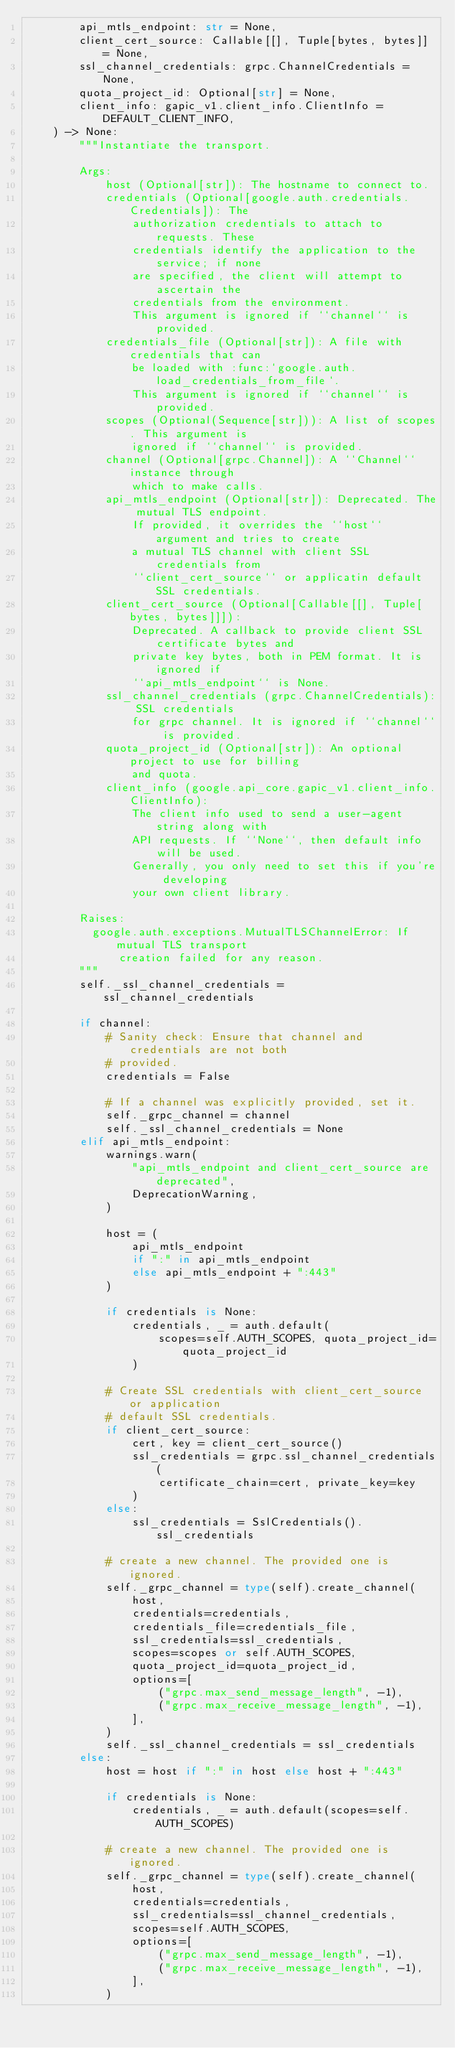Convert code to text. <code><loc_0><loc_0><loc_500><loc_500><_Python_>        api_mtls_endpoint: str = None,
        client_cert_source: Callable[[], Tuple[bytes, bytes]] = None,
        ssl_channel_credentials: grpc.ChannelCredentials = None,
        quota_project_id: Optional[str] = None,
        client_info: gapic_v1.client_info.ClientInfo = DEFAULT_CLIENT_INFO,
    ) -> None:
        """Instantiate the transport.

        Args:
            host (Optional[str]): The hostname to connect to.
            credentials (Optional[google.auth.credentials.Credentials]): The
                authorization credentials to attach to requests. These
                credentials identify the application to the service; if none
                are specified, the client will attempt to ascertain the
                credentials from the environment.
                This argument is ignored if ``channel`` is provided.
            credentials_file (Optional[str]): A file with credentials that can
                be loaded with :func:`google.auth.load_credentials_from_file`.
                This argument is ignored if ``channel`` is provided.
            scopes (Optional(Sequence[str])): A list of scopes. This argument is
                ignored if ``channel`` is provided.
            channel (Optional[grpc.Channel]): A ``Channel`` instance through
                which to make calls.
            api_mtls_endpoint (Optional[str]): Deprecated. The mutual TLS endpoint.
                If provided, it overrides the ``host`` argument and tries to create
                a mutual TLS channel with client SSL credentials from
                ``client_cert_source`` or applicatin default SSL credentials.
            client_cert_source (Optional[Callable[[], Tuple[bytes, bytes]]]):
                Deprecated. A callback to provide client SSL certificate bytes and
                private key bytes, both in PEM format. It is ignored if
                ``api_mtls_endpoint`` is None.
            ssl_channel_credentials (grpc.ChannelCredentials): SSL credentials
                for grpc channel. It is ignored if ``channel`` is provided.
            quota_project_id (Optional[str]): An optional project to use for billing
                and quota.
            client_info (google.api_core.gapic_v1.client_info.ClientInfo):
                The client info used to send a user-agent string along with
                API requests. If ``None``, then default info will be used.
                Generally, you only need to set this if you're developing
                your own client library.

        Raises:
          google.auth.exceptions.MutualTLSChannelError: If mutual TLS transport
              creation failed for any reason.
        """
        self._ssl_channel_credentials = ssl_channel_credentials

        if channel:
            # Sanity check: Ensure that channel and credentials are not both
            # provided.
            credentials = False

            # If a channel was explicitly provided, set it.
            self._grpc_channel = channel
            self._ssl_channel_credentials = None
        elif api_mtls_endpoint:
            warnings.warn(
                "api_mtls_endpoint and client_cert_source are deprecated",
                DeprecationWarning,
            )

            host = (
                api_mtls_endpoint
                if ":" in api_mtls_endpoint
                else api_mtls_endpoint + ":443"
            )

            if credentials is None:
                credentials, _ = auth.default(
                    scopes=self.AUTH_SCOPES, quota_project_id=quota_project_id
                )

            # Create SSL credentials with client_cert_source or application
            # default SSL credentials.
            if client_cert_source:
                cert, key = client_cert_source()
                ssl_credentials = grpc.ssl_channel_credentials(
                    certificate_chain=cert, private_key=key
                )
            else:
                ssl_credentials = SslCredentials().ssl_credentials

            # create a new channel. The provided one is ignored.
            self._grpc_channel = type(self).create_channel(
                host,
                credentials=credentials,
                credentials_file=credentials_file,
                ssl_credentials=ssl_credentials,
                scopes=scopes or self.AUTH_SCOPES,
                quota_project_id=quota_project_id,
                options=[
                    ("grpc.max_send_message_length", -1),
                    ("grpc.max_receive_message_length", -1),
                ],
            )
            self._ssl_channel_credentials = ssl_credentials
        else:
            host = host if ":" in host else host + ":443"

            if credentials is None:
                credentials, _ = auth.default(scopes=self.AUTH_SCOPES)

            # create a new channel. The provided one is ignored.
            self._grpc_channel = type(self).create_channel(
                host,
                credentials=credentials,
                ssl_credentials=ssl_channel_credentials,
                scopes=self.AUTH_SCOPES,
                options=[
                    ("grpc.max_send_message_length", -1),
                    ("grpc.max_receive_message_length", -1),
                ],
            )
</code> 